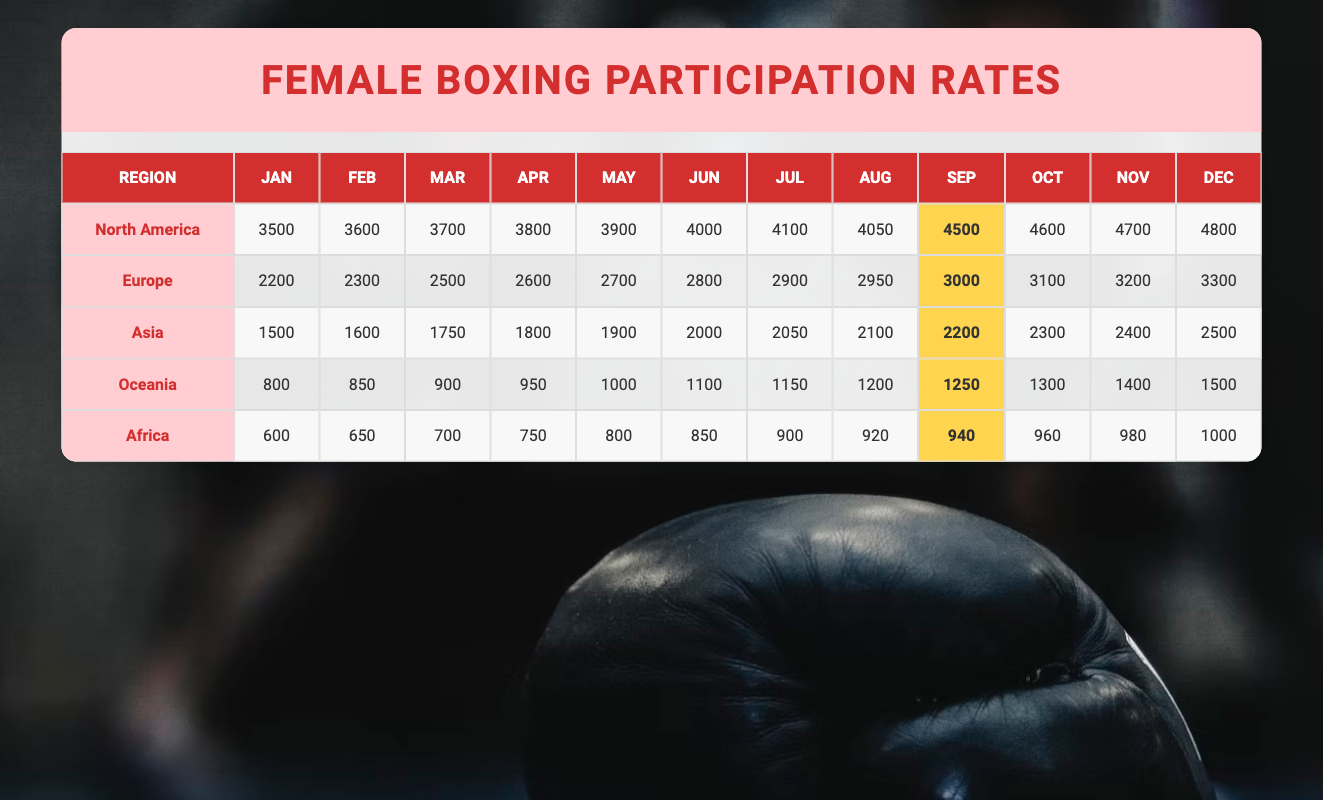What is the total number of female athletes participating in boxing in North America in December? From the table, the value for North America in December is 4800.
Answer: 4800 Which region had the highest participation in October? The values for October are: North America (4600), Europe (3100), Asia (2300), Oceania (1300), and Africa (960). North America has the highest at 4600.
Answer: North America What is the difference in participation between North America and Europe in March? In March, North America has 3700 fighters, while Europe has 2500. The difference is calculated as 3700 - 2500 = 1200.
Answer: 1200 Which region has the lowest participation rate in January? The values for January are: North America (3500), Europe (2200), Asia (1500), Oceania (800), and Africa (600). Africa has the lowest at 600.
Answer: Africa What is the average participation of female athletes from Asia over the entire year? The total participation for Asia is (1500 + 1600 + 1750 + 1800 + 1900 + 2000 + 2050 + 2100 + 2200 + 2300 + 2400 + 2500) = 23,100. Dividing by 12 months gives an average of 23,100 / 12 = 1925.
Answer: 1925 Was there an increase in participation from July to August in Oceania? In July, Oceania had 1150 participants and in August 1200. Since 1200 is greater than 1150, there was an increase.
Answer: Yes How many female athletes participated in total across all regions in September? Adding the September values: North America (4500) + Europe (3000) + Asia (2200) + Oceania (1250) + Africa (940) gives 4500 + 3000 + 2200 + 1250 + 940 = 12,890.
Answer: 12890 Which month saw the highest participation for Europe? The highest value for Europe is in December at 3300, as seen in the table.
Answer: December Is the monthly participation of female athletes in Africa steadily increasing throughout the year? The values are: 600, 650, 700, 750, 800, 850, 900, 920, 940, 960, 980, 1000. Each value is greater than the previous one, indicating a steady increase.
Answer: Yes What is the median participation rate for female athletes in Oceania? The participation values for Oceania are: 800, 850, 900, 950, 1000, 1100, 1150, 1200, 1250, 1300, 1400, 1500. The median (average of 1150 and 1200, which are 6th and 7th in a sorted list) [(1150 + 1200) / 2] = 1175.
Answer: 1175 Which region has a total participation less than 3000 in April? The values for April are: North America (3800), Europe (2600), Asia (1800), Oceania (950), and Africa (750). Only Asia (1800) and Africa (750) have totals less than 3000.
Answer: Asia, Africa 